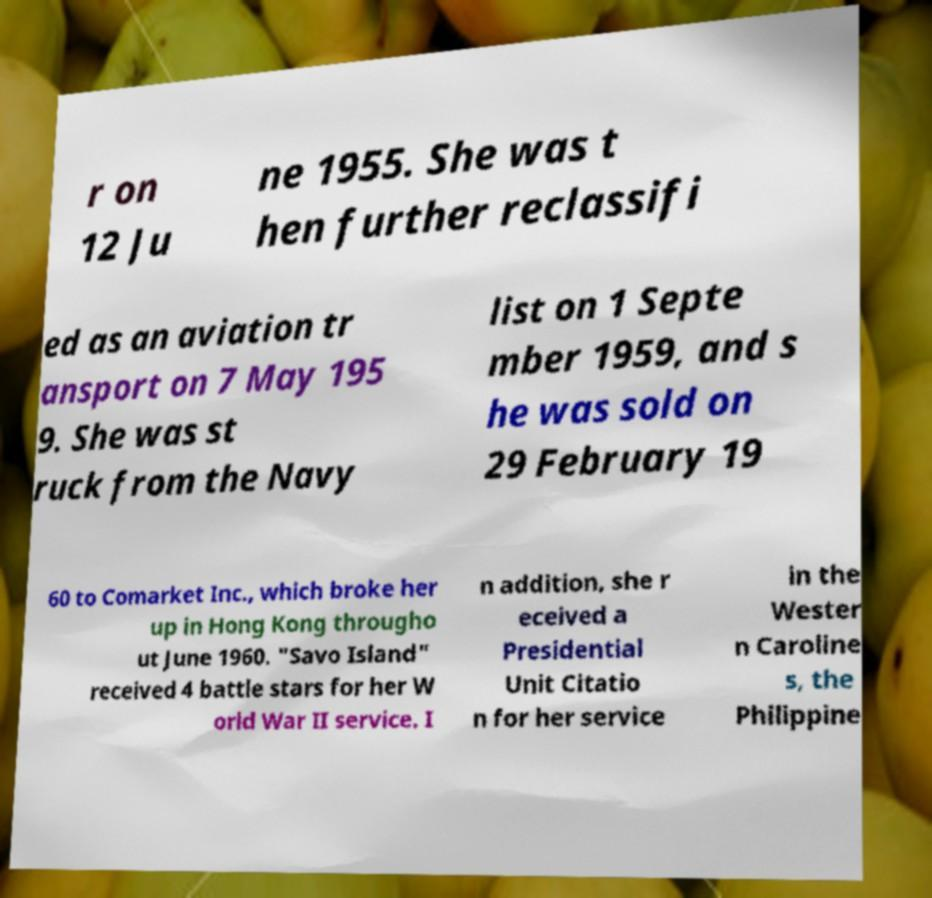There's text embedded in this image that I need extracted. Can you transcribe it verbatim? r on 12 Ju ne 1955. She was t hen further reclassifi ed as an aviation tr ansport on 7 May 195 9. She was st ruck from the Navy list on 1 Septe mber 1959, and s he was sold on 29 February 19 60 to Comarket Inc., which broke her up in Hong Kong througho ut June 1960. "Savo Island" received 4 battle stars for her W orld War II service. I n addition, she r eceived a Presidential Unit Citatio n for her service in the Wester n Caroline s, the Philippine 